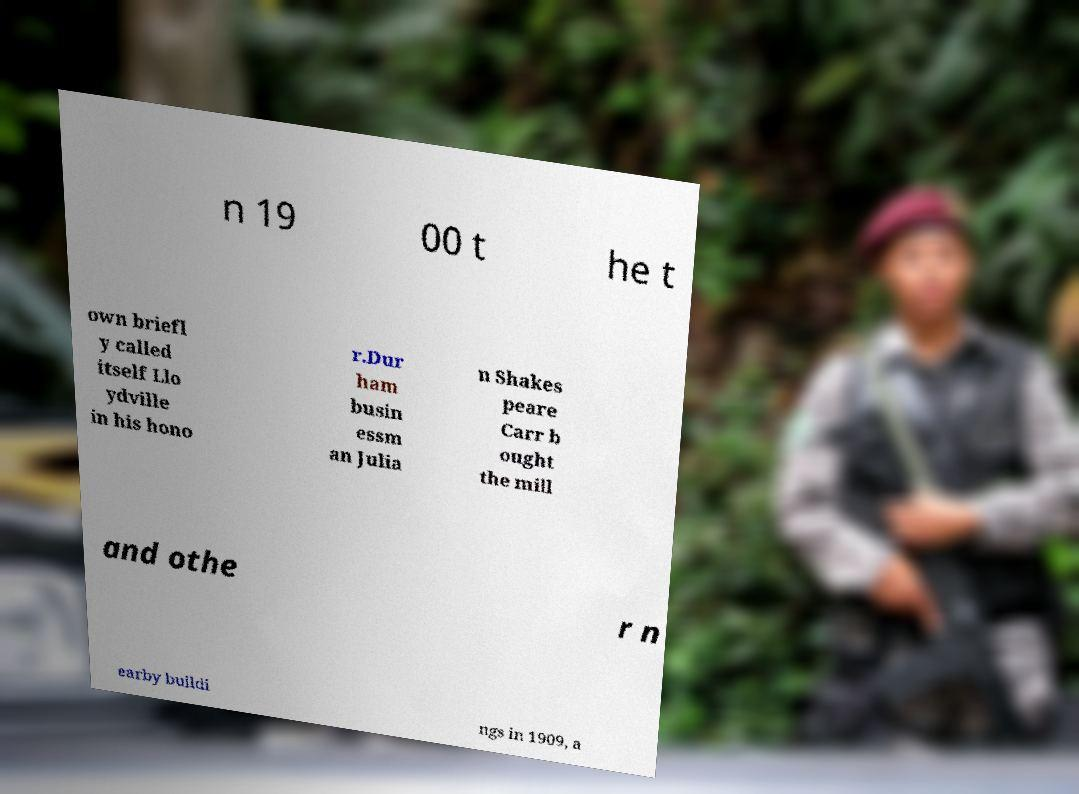Could you assist in decoding the text presented in this image and type it out clearly? n 19 00 t he t own briefl y called itself Llo ydville in his hono r.Dur ham busin essm an Julia n Shakes peare Carr b ought the mill and othe r n earby buildi ngs in 1909, a 